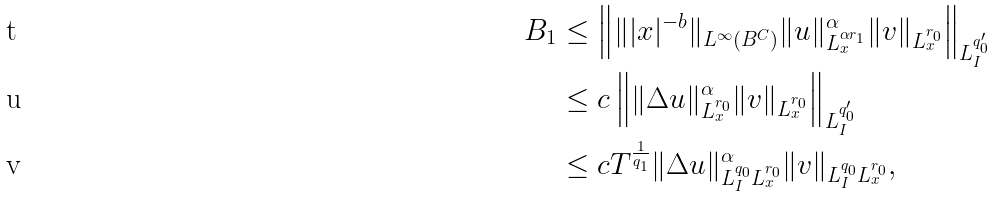Convert formula to latex. <formula><loc_0><loc_0><loc_500><loc_500>B _ { 1 } & \leq \left \| \| | x | ^ { - b } \| _ { L ^ { \infty } ( B ^ { C } ) } \| u \| ^ { \alpha } _ { L _ { x } ^ { \alpha r _ { 1 } } } \| v \| _ { L ^ { r _ { 0 } } _ { x } } \right \| _ { L ^ { q ^ { \prime } _ { 0 } } _ { I } } \\ & \leq c \left \| \| \Delta u \| ^ { \alpha } _ { L _ { x } ^ { r _ { 0 } } } \| v \| _ { L ^ { r _ { 0 } } _ { x } } \right \| _ { L ^ { q ^ { \prime } _ { 0 } } _ { I } } \\ & \leq c T ^ { \frac { 1 } { q _ { 1 } } } \| \Delta u \| ^ { \alpha } _ { L _ { I } ^ { q _ { 0 } } L ^ { r _ { 0 } } _ { x } } \| v \| _ { L ^ { q _ { 0 } } _ { I } L _ { x } ^ { r _ { 0 } } } ,</formula> 